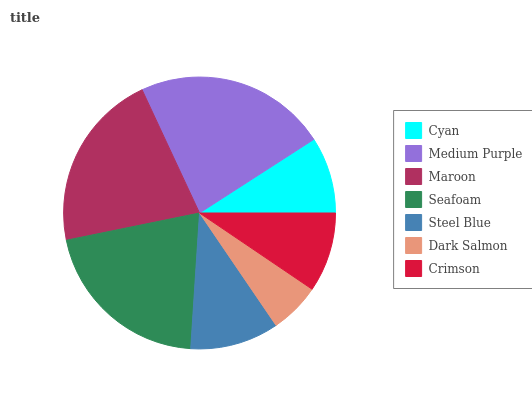Is Dark Salmon the minimum?
Answer yes or no. Yes. Is Medium Purple the maximum?
Answer yes or no. Yes. Is Maroon the minimum?
Answer yes or no. No. Is Maroon the maximum?
Answer yes or no. No. Is Medium Purple greater than Maroon?
Answer yes or no. Yes. Is Maroon less than Medium Purple?
Answer yes or no. Yes. Is Maroon greater than Medium Purple?
Answer yes or no. No. Is Medium Purple less than Maroon?
Answer yes or no. No. Is Steel Blue the high median?
Answer yes or no. Yes. Is Steel Blue the low median?
Answer yes or no. Yes. Is Seafoam the high median?
Answer yes or no. No. Is Seafoam the low median?
Answer yes or no. No. 